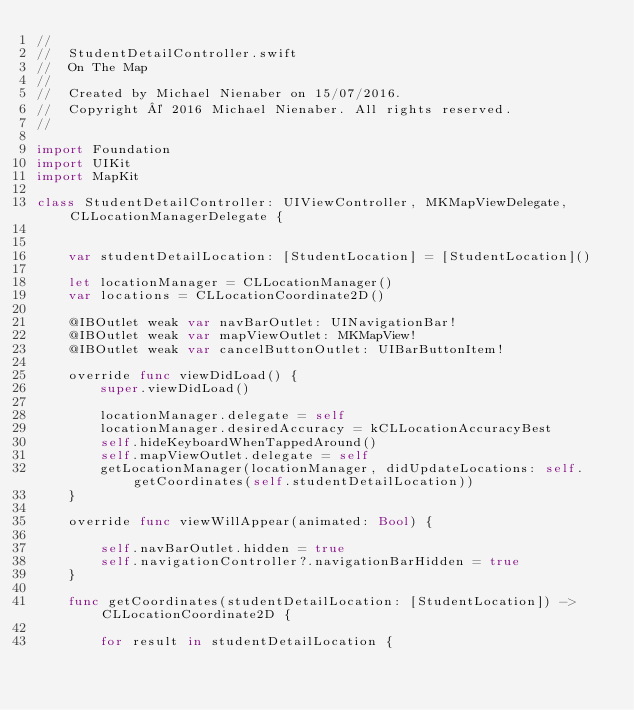<code> <loc_0><loc_0><loc_500><loc_500><_Swift_>//
//  StudentDetailController.swift
//  On The Map
//
//  Created by Michael Nienaber on 15/07/2016.
//  Copyright © 2016 Michael Nienaber. All rights reserved.
//

import Foundation
import UIKit
import MapKit

class StudentDetailController: UIViewController, MKMapViewDelegate, CLLocationManagerDelegate {
    
    
    var studentDetailLocation: [StudentLocation] = [StudentLocation]()
    
    let locationManager = CLLocationManager()
    var locations = CLLocationCoordinate2D()
    
    @IBOutlet weak var navBarOutlet: UINavigationBar!
    @IBOutlet weak var mapViewOutlet: MKMapView!
    @IBOutlet weak var cancelButtonOutlet: UIBarButtonItem!

    override func viewDidLoad() {
        super.viewDidLoad()

        locationManager.delegate = self
        locationManager.desiredAccuracy = kCLLocationAccuracyBest
        self.hideKeyboardWhenTappedAround()
        self.mapViewOutlet.delegate = self
        getLocationManager(locationManager, didUpdateLocations: self.getCoordinates(self.studentDetailLocation))
    }
    
    override func viewWillAppear(animated: Bool) {
        
        self.navBarOutlet.hidden = true
        self.navigationController?.navigationBarHidden = true
    }
    
    func getCoordinates(studentDetailLocation: [StudentLocation]) -> CLLocationCoordinate2D {
        
        for result in studentDetailLocation {
            </code> 